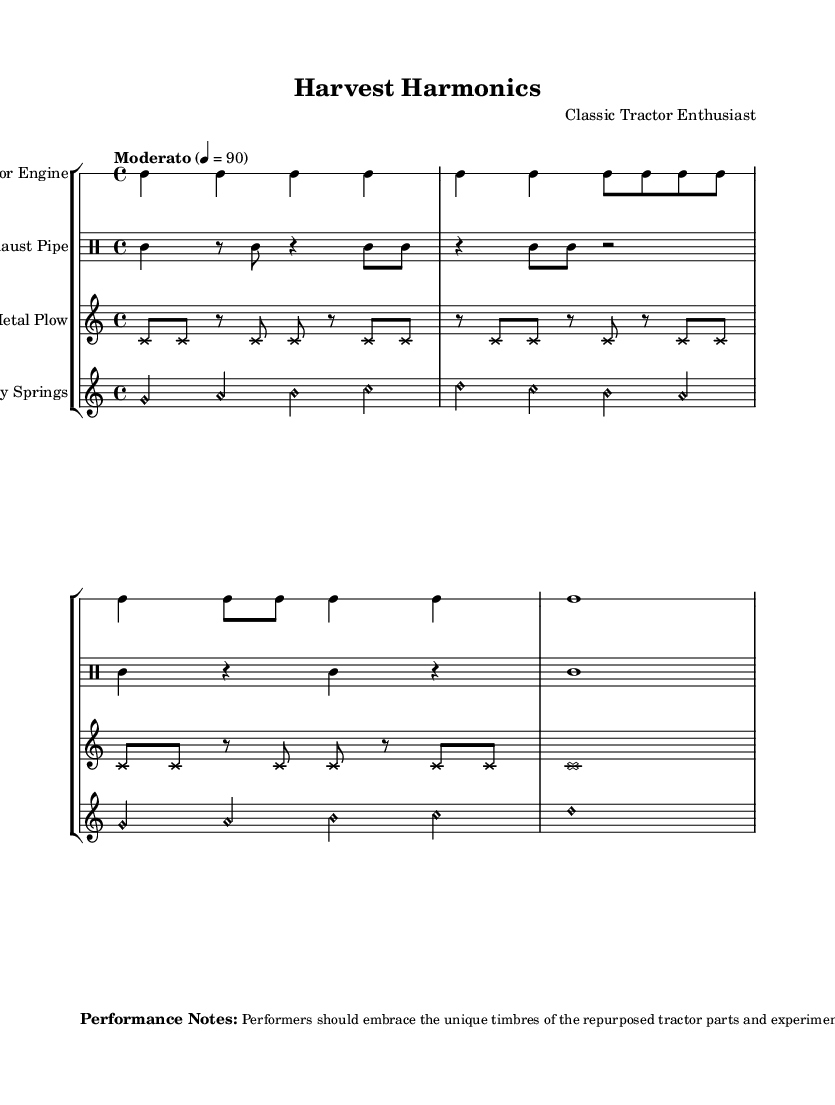What is the time signature of this composition? The time signature is indicated by the notation "4/4" at the beginning of the global music block.
Answer: 4/4 What instruments are featured in this experimental composition? The instruments are listed under the "StaffGroup" section as "Tractor Engine," "Exhaust Pipe," "Metal Plow," and "Rusty Springs."
Answer: Tractor Engine, Exhaust Pipe, Metal Plow, Rusty Springs What is the tempo marking for this piece? The tempo is specified as "Moderato" with a beat of 90 in quarter notes, shown at the beginning of the global section.
Answer: Moderato Which instrument uses cross note heads? The "Metal Plow" section has an override indicating that its note head style is set to 'cross.'
Answer: Metal Plow How many measures are there in the "Tractor Engine" part? The "Tractor Engine" part is composed of four measures, determined by the distinct groups of beats separated by the bar lines in the drummode.
Answer: Four measures What extended techniques are suggested for performers? The performance notes suggest that performers embrace unique timbres of the repurposed tractor parts and experiment with various extended techniques for a rich soundscape.
Answer: Unique timbres, extended techniques What type of soundscape does the composer aim to create? The performance notes mention a "rich, textural soundscape," highlighting the importance of diverse sounds from the tractor parts.
Answer: Rich, textural soundscape 